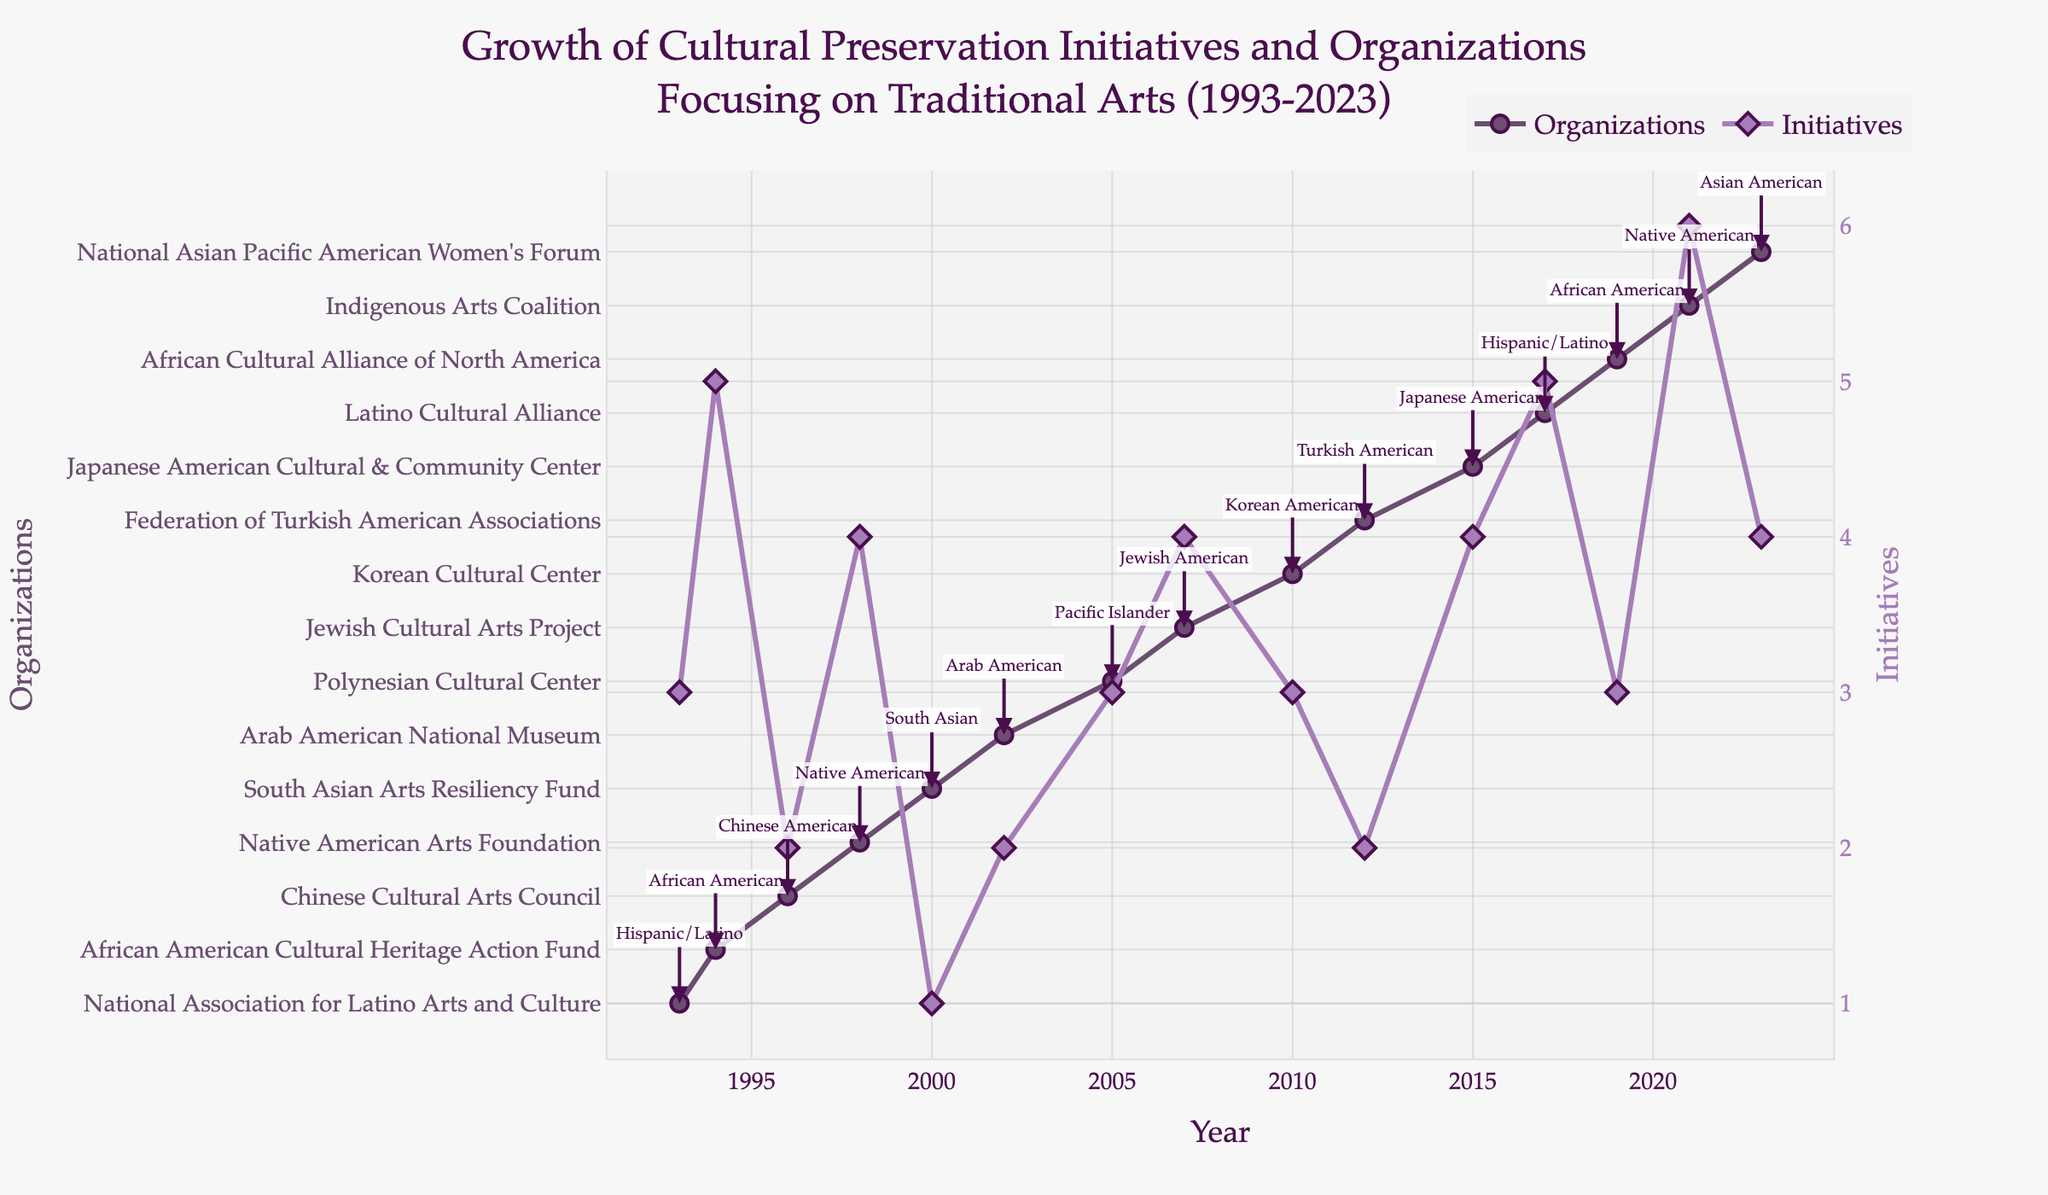What is the time range covered by the plot? The x-axis of the plot is labeled with years, and the range of these years is from 1993 to 2023.
Answer: 1993 to 2023 Which ethnic group initiative was introduced in 2002? By looking at the annotation on the figure for the year 2002, it mentions the Arab American National Museum. The ethnic group referenced is Arab American.
Answer: Arab American How many organizations focused on traditional arts were established by 2023? The highest y-value for the Organizations series in the year 2023 marked is 4.
Answer: 4 Which initiative had the highest value and what year was it introduced? The y-axis for Initiatives indicates the highest value of 6, which occurs around the year 2021. According to the plot, this corresponds to the Indigenous Arts Coalition.
Answer: Indigenous Arts Coalition, 2021 Compare the number of organizations introduced in 1998 to those in 2012. Which year had more, and by how much? From the y-values in the plot, 1998 has 4 organizations while 2012 has 2 organizations. Subtracting the 1998 value from the 2012 value gives a difference of 2.
Answer: 1998, by 2 Which ethnic group's initiative value increased the most between its introduction and its latest data point? By observing the Initiatives values, the Native American initiatives show a significant increase from 4 in 1998 to 6 by 2021, an increase of 2.
Answer: Native American In what year did the number of Korean American organizations appear, and how many were there? The annotations in the year 2010 indicate the Korean Cultural Center with 3 organizations.
Answer: 2010, 3 Calculate the average number of initiatives introduced in the years 2000, 2002, and 2005. The initiatives introduced in 2000, 2002, and 2005 have values 1, 2, and 3 respectively. Adding these gives 1 + 2 + 3 = 6, and the average is 6/3 = 2.
Answer: 2 When was the Jewish Cultural Arts Project introduced, and how many initiatives were associated with it? The annotation for 2007 mentions the Jewish Cultural Arts Project with 4 initiatives.
Answer: 2007, 4 